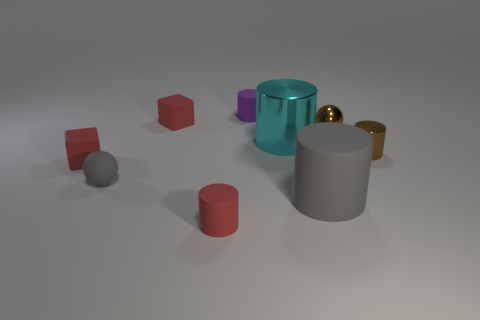Subtract all metal cylinders. How many cylinders are left? 3 Subtract all gray cylinders. How many cylinders are left? 4 Subtract all cubes. How many objects are left? 7 Subtract 2 cubes. How many cubes are left? 0 Add 3 brown metal things. How many brown metal things are left? 5 Add 4 small brown balls. How many small brown balls exist? 5 Subtract 0 blue cubes. How many objects are left? 9 Subtract all gray cylinders. Subtract all blue balls. How many cylinders are left? 4 Subtract all tiny gray rubber balls. Subtract all tiny matte things. How many objects are left? 3 